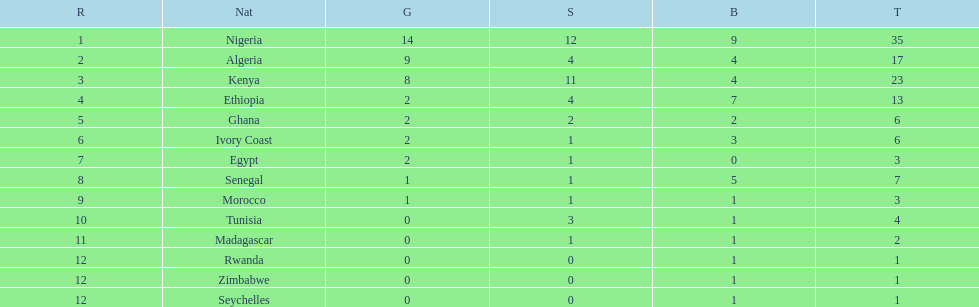How many silver medals did kenya earn? 11. 